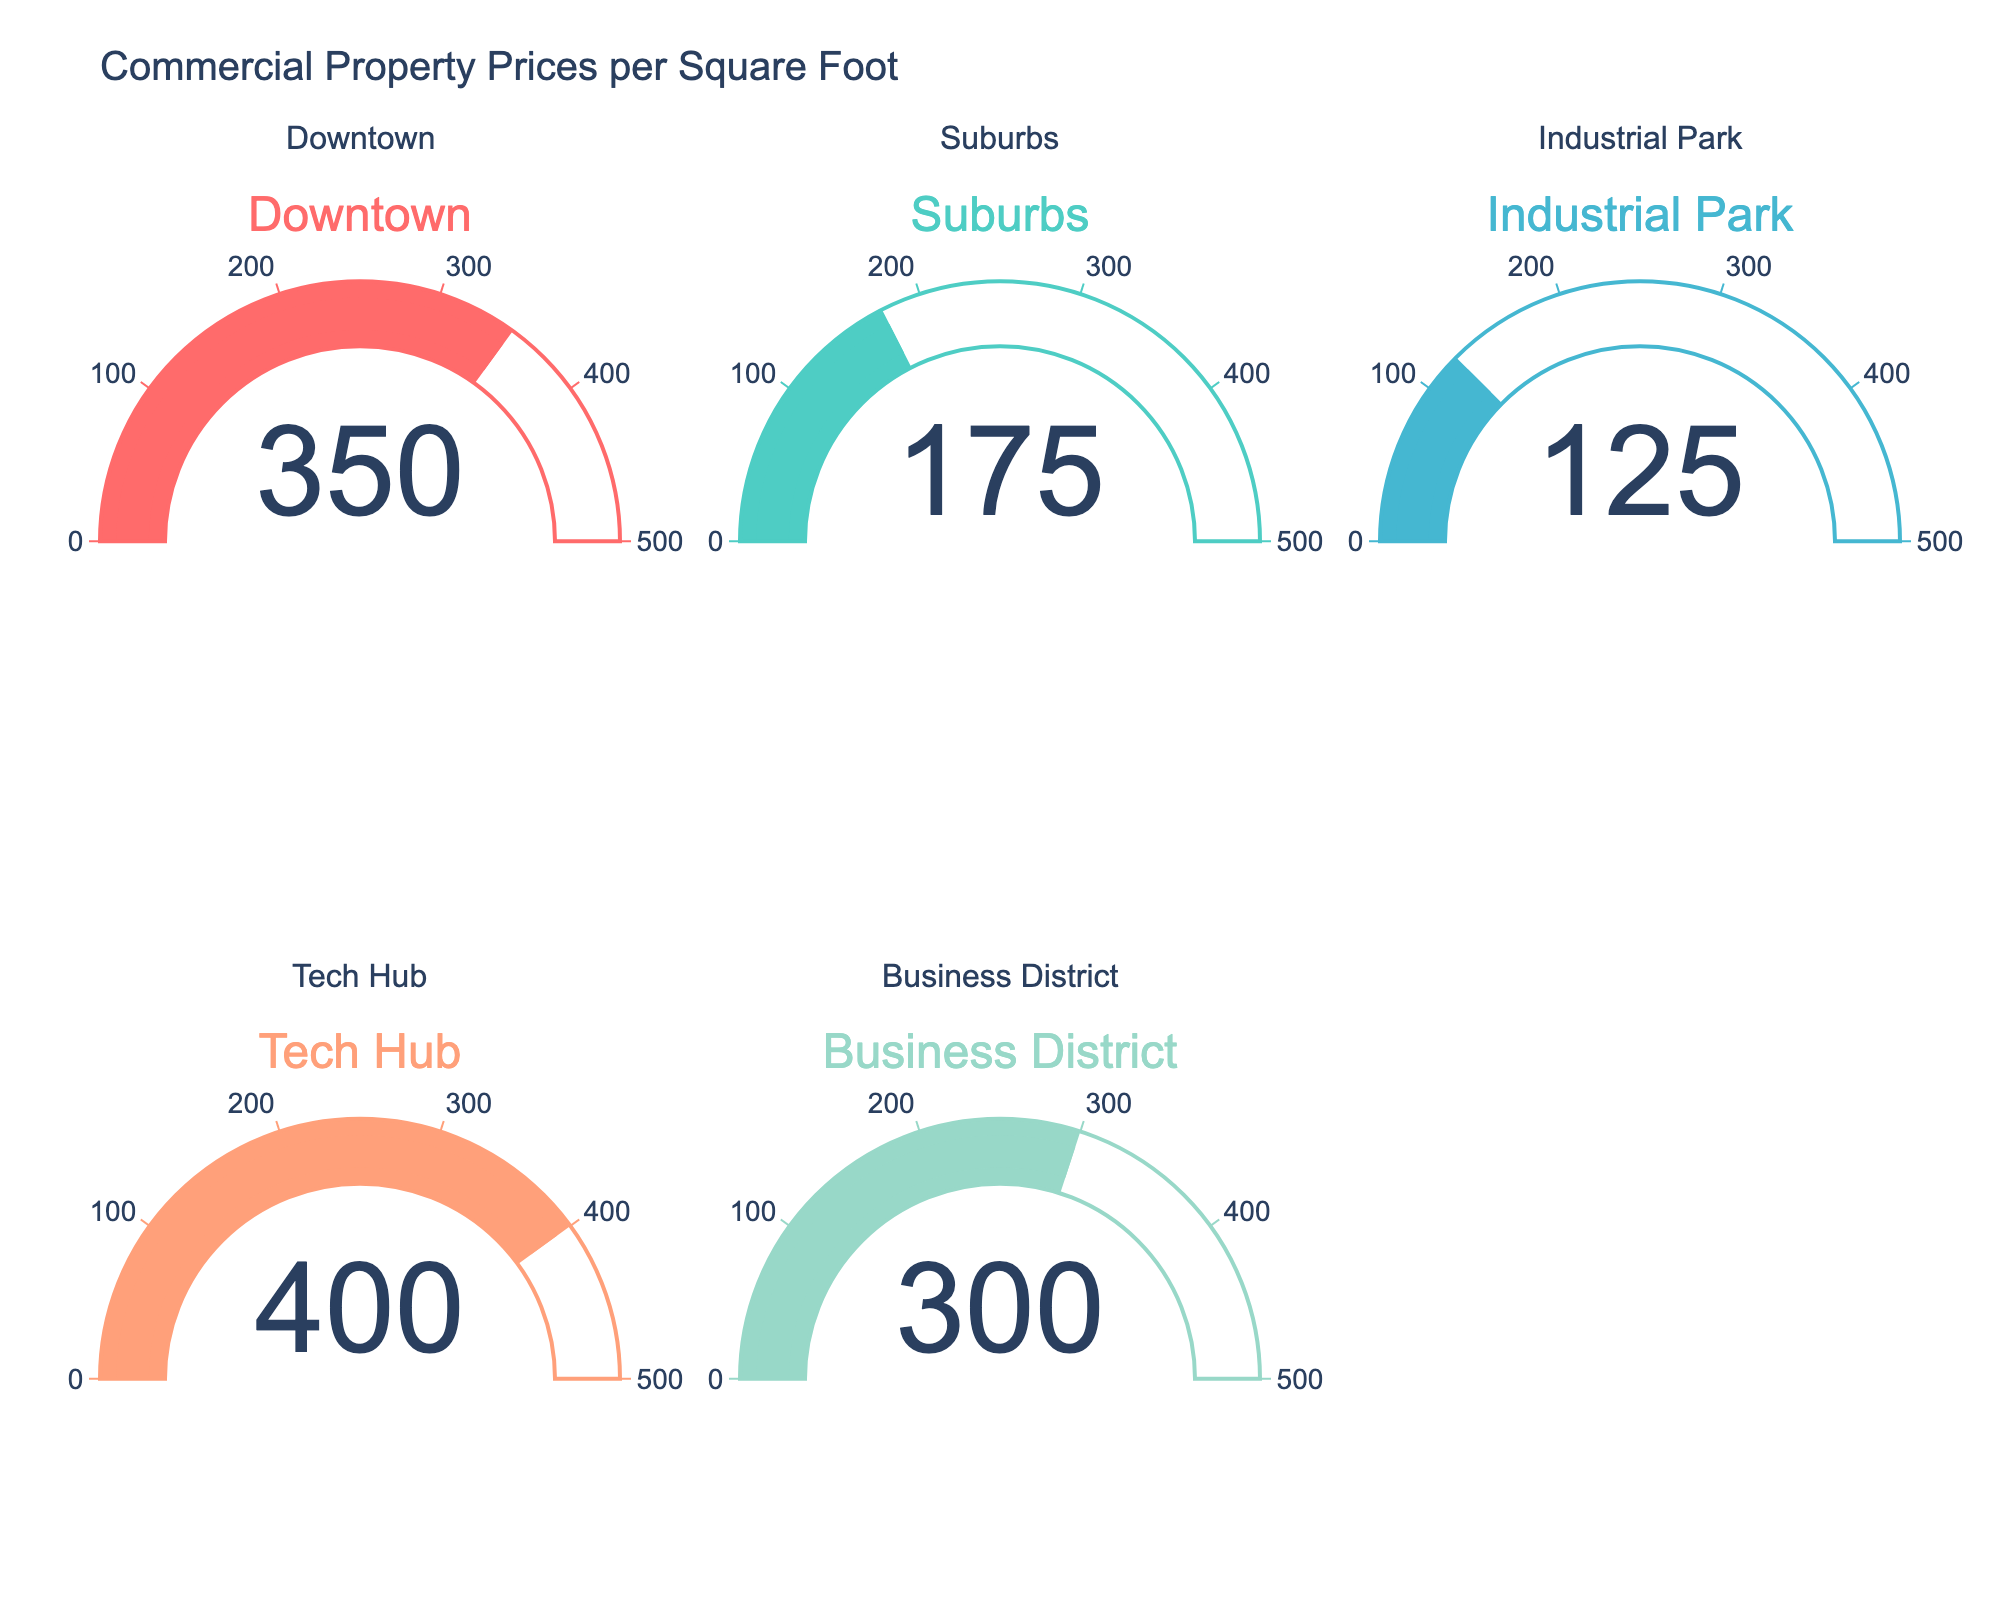What's the highest price per square foot among the locations? The gauge chart shows the price per square foot for each location. Identify the highest number displayed. In the figure, Tech Hub has the highest price per square foot.
Answer: Tech Hub Which location has the lowest price per square foot? The gauge chart shows the price per square foot for each location. Identify the lowest number displayed. In the figure, Industrial Park has the lowest price per square foot.
Answer: Industrial Park What is the average price per square foot across all the locations? Add the price per square foot for Downtown (350), Suburbs (175), Industrial Park (125), Tech Hub (400), and Business District (300). Then divide by the number of locations (5). (350 + 175 + 125 + 400 + 300) / 5 = 1350 / 5 = 270
Answer: 270 How much more expensive is Tech Hub compared to Industrial Park per square foot? Subtract the price per square foot of Industrial Park (125) from the price per square foot of Tech Hub (400). 400 - 125 = 275
Answer: 275 Which two locations have the price per square foot closest to each other? Compare the values of all pairs of locations and find the pair with the smallest difference. Downtown (350) and Business District (300) have the smallest difference.
Answer: Downtown and Business District What percentage of the highest price per square foot is the lowest price per square foot? Divide the lowest value (125) by the highest value (400) and multiply by 100 to get the percentage. (125 / 400) * 100 = 31.25%
Answer: 31.25% Is there any location with a price per square foot above 300? Examine each price per square foot and see if any exceed 300. Both Downtown (350) and Tech Hub (400) exceed 300.
Answer: Yes By how much does the price per square foot of Downtown exceed the average price per square foot? Subtract the average price per square foot (270, calculated earlier) from the price per square foot of Downtown (350). 350 - 270 = 80
Answer: 80 If the price per square foot in Suburbs increased by 20%, what would the new value be? Calculate 20% of the Suburbs' value (175) and add it to the original value. 20% of 175 = 0.20 * 175 = 35. New value = 175 + 35 = 210
Answer: 210 